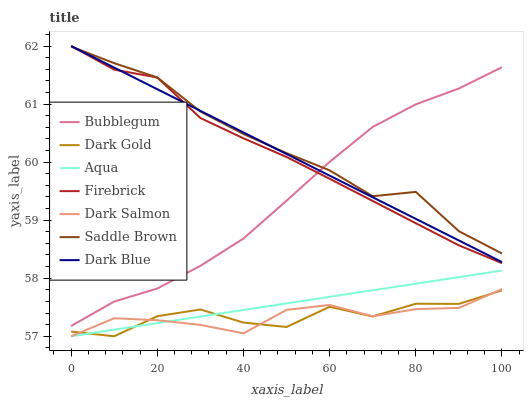Does Dark Salmon have the minimum area under the curve?
Answer yes or no. Yes. Does Saddle Brown have the maximum area under the curve?
Answer yes or no. Yes. Does Firebrick have the minimum area under the curve?
Answer yes or no. No. Does Firebrick have the maximum area under the curve?
Answer yes or no. No. Is Aqua the smoothest?
Answer yes or no. Yes. Is Dark Gold the roughest?
Answer yes or no. Yes. Is Firebrick the smoothest?
Answer yes or no. No. Is Firebrick the roughest?
Answer yes or no. No. Does Firebrick have the lowest value?
Answer yes or no. No. Does Aqua have the highest value?
Answer yes or no. No. Is Aqua less than Bubblegum?
Answer yes or no. Yes. Is Firebrick greater than Dark Gold?
Answer yes or no. Yes. Does Aqua intersect Bubblegum?
Answer yes or no. No. 